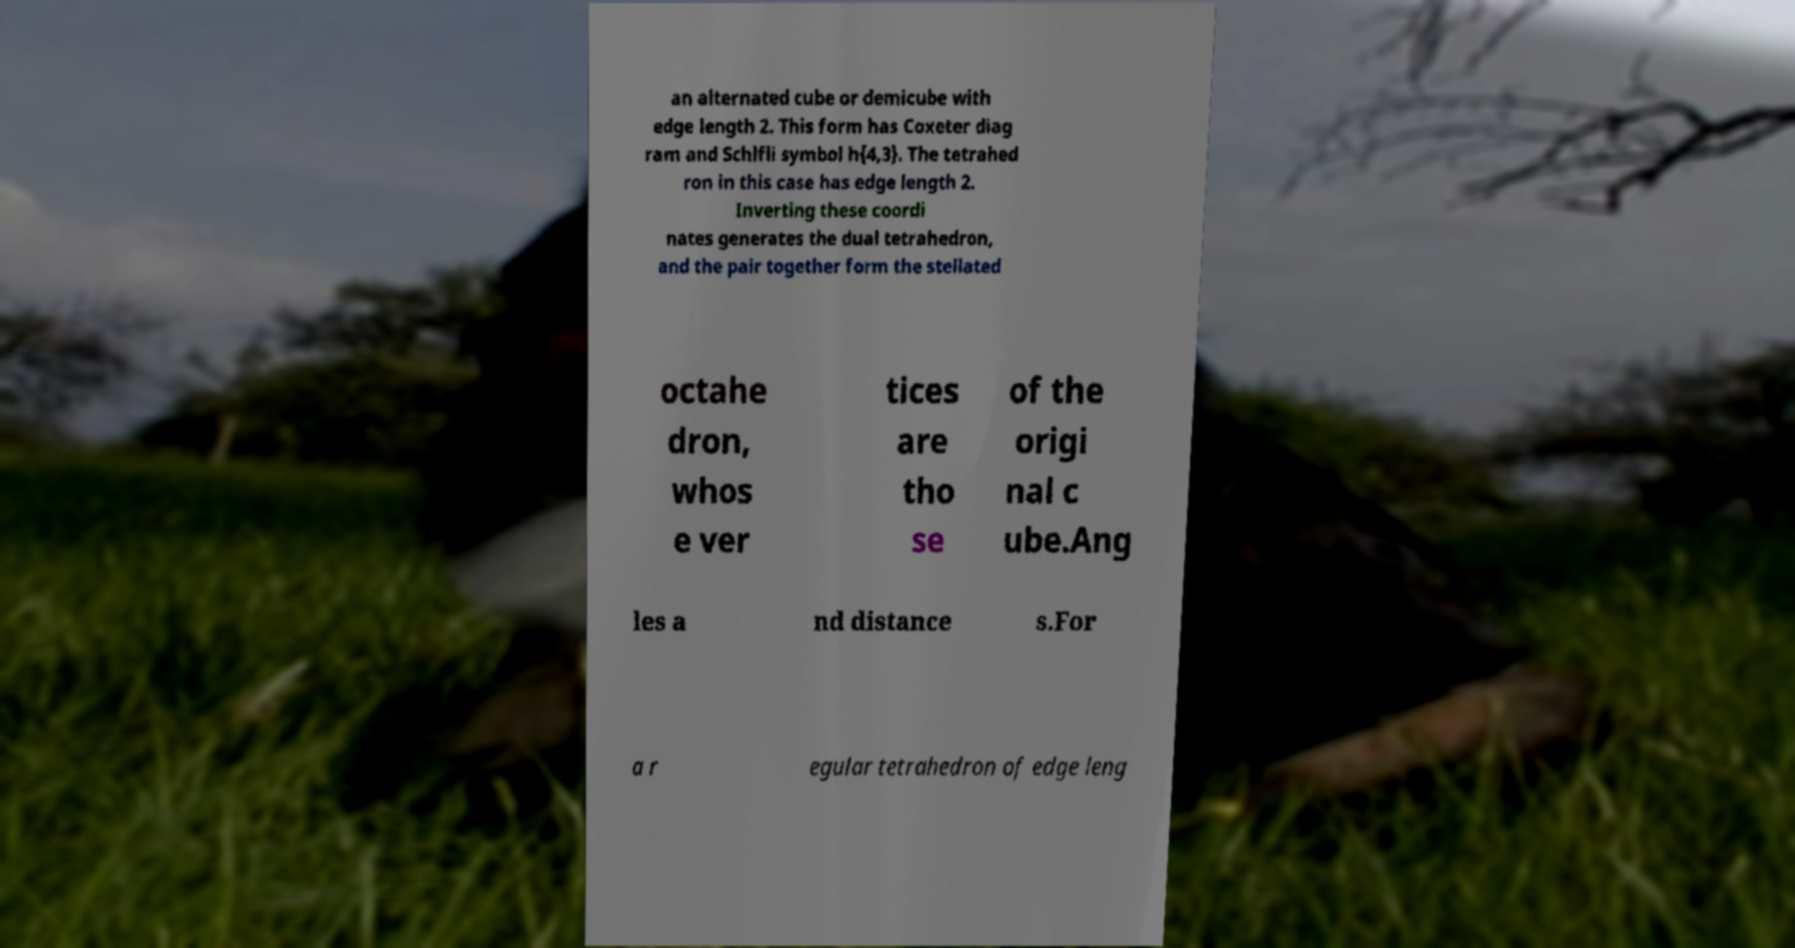I need the written content from this picture converted into text. Can you do that? an alternated cube or demicube with edge length 2. This form has Coxeter diag ram and Schlfli symbol h{4,3}. The tetrahed ron in this case has edge length 2. Inverting these coordi nates generates the dual tetrahedron, and the pair together form the stellated octahe dron, whos e ver tices are tho se of the origi nal c ube.Ang les a nd distance s.For a r egular tetrahedron of edge leng 